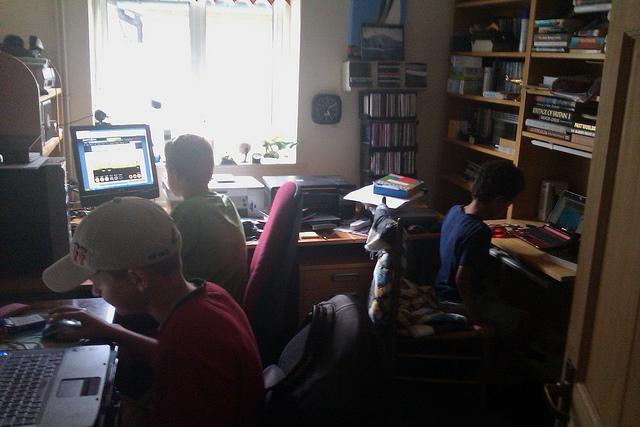How many people are in the photo?
Give a very brief answer. 3. How many chairs can be seen?
Give a very brief answer. 3. How many people can be seen?
Give a very brief answer. 3. How many keyboards are in the photo?
Give a very brief answer. 1. 